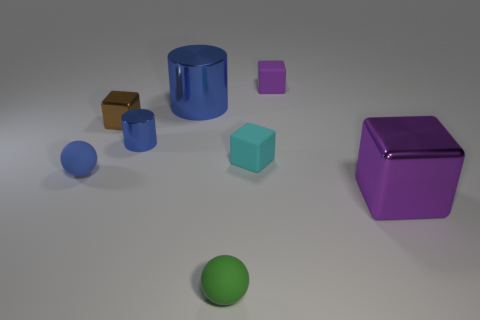Can you describe the texture of the objects in the scene? Certainly! The objects exhibit a variety of textures. The blue cylinder and the purple cube have a glossy finish, reflecting light and giving a smooth appearance. The metal block and the green sphere have a matte finish, diffusing the light and giving a more subdued look. The remaining small blue cube and the brown cube on the left appear to have a slightly textured surface that's not as reflective as the glossy objects. 